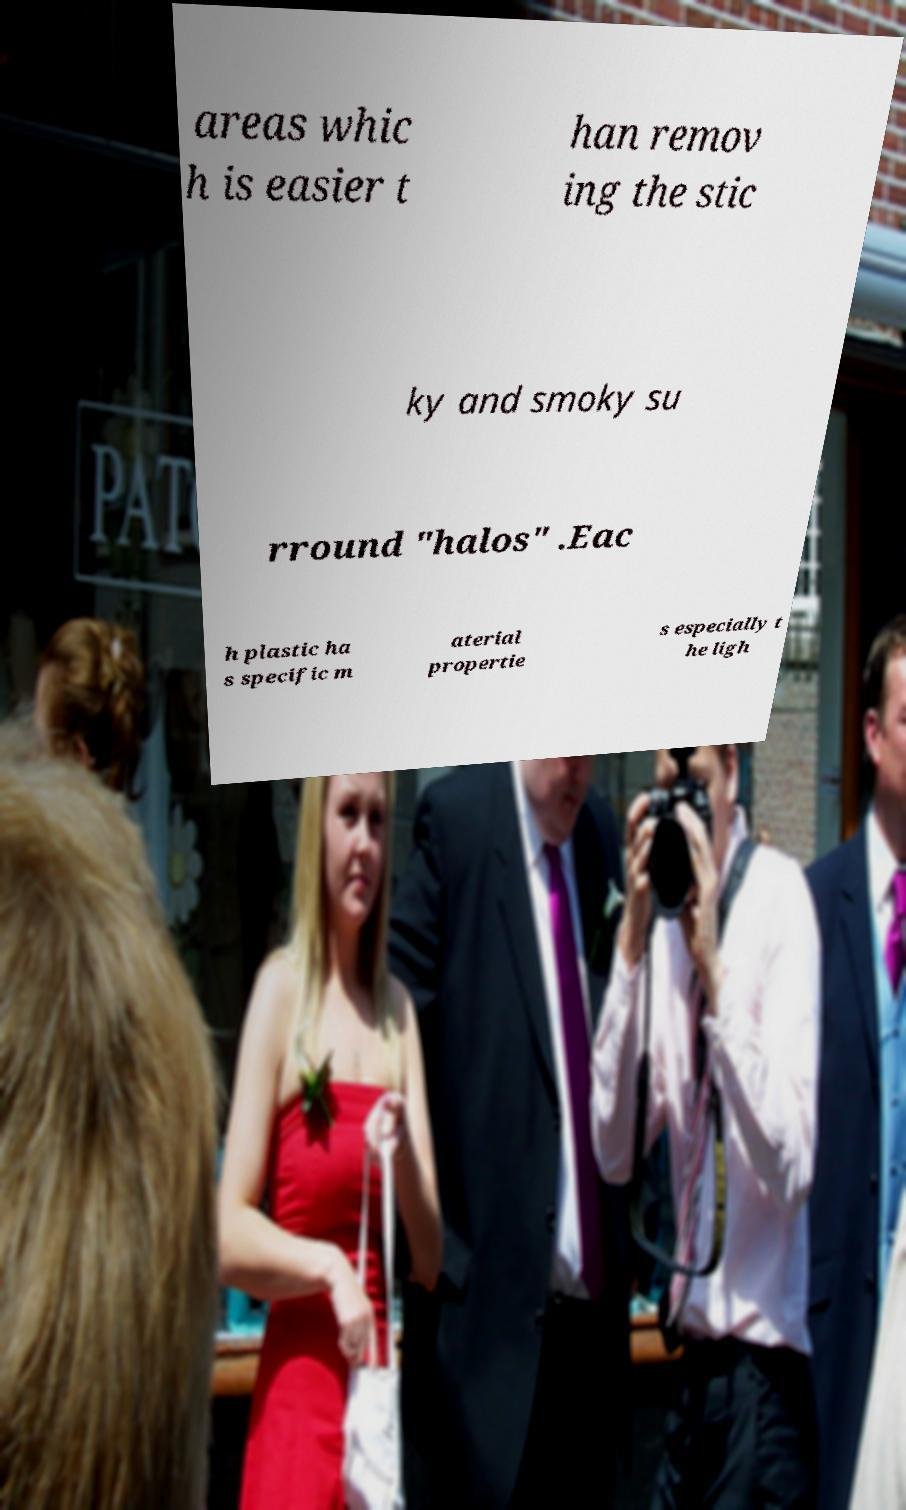Could you assist in decoding the text presented in this image and type it out clearly? areas whic h is easier t han remov ing the stic ky and smoky su rround "halos" .Eac h plastic ha s specific m aterial propertie s especially t he ligh 